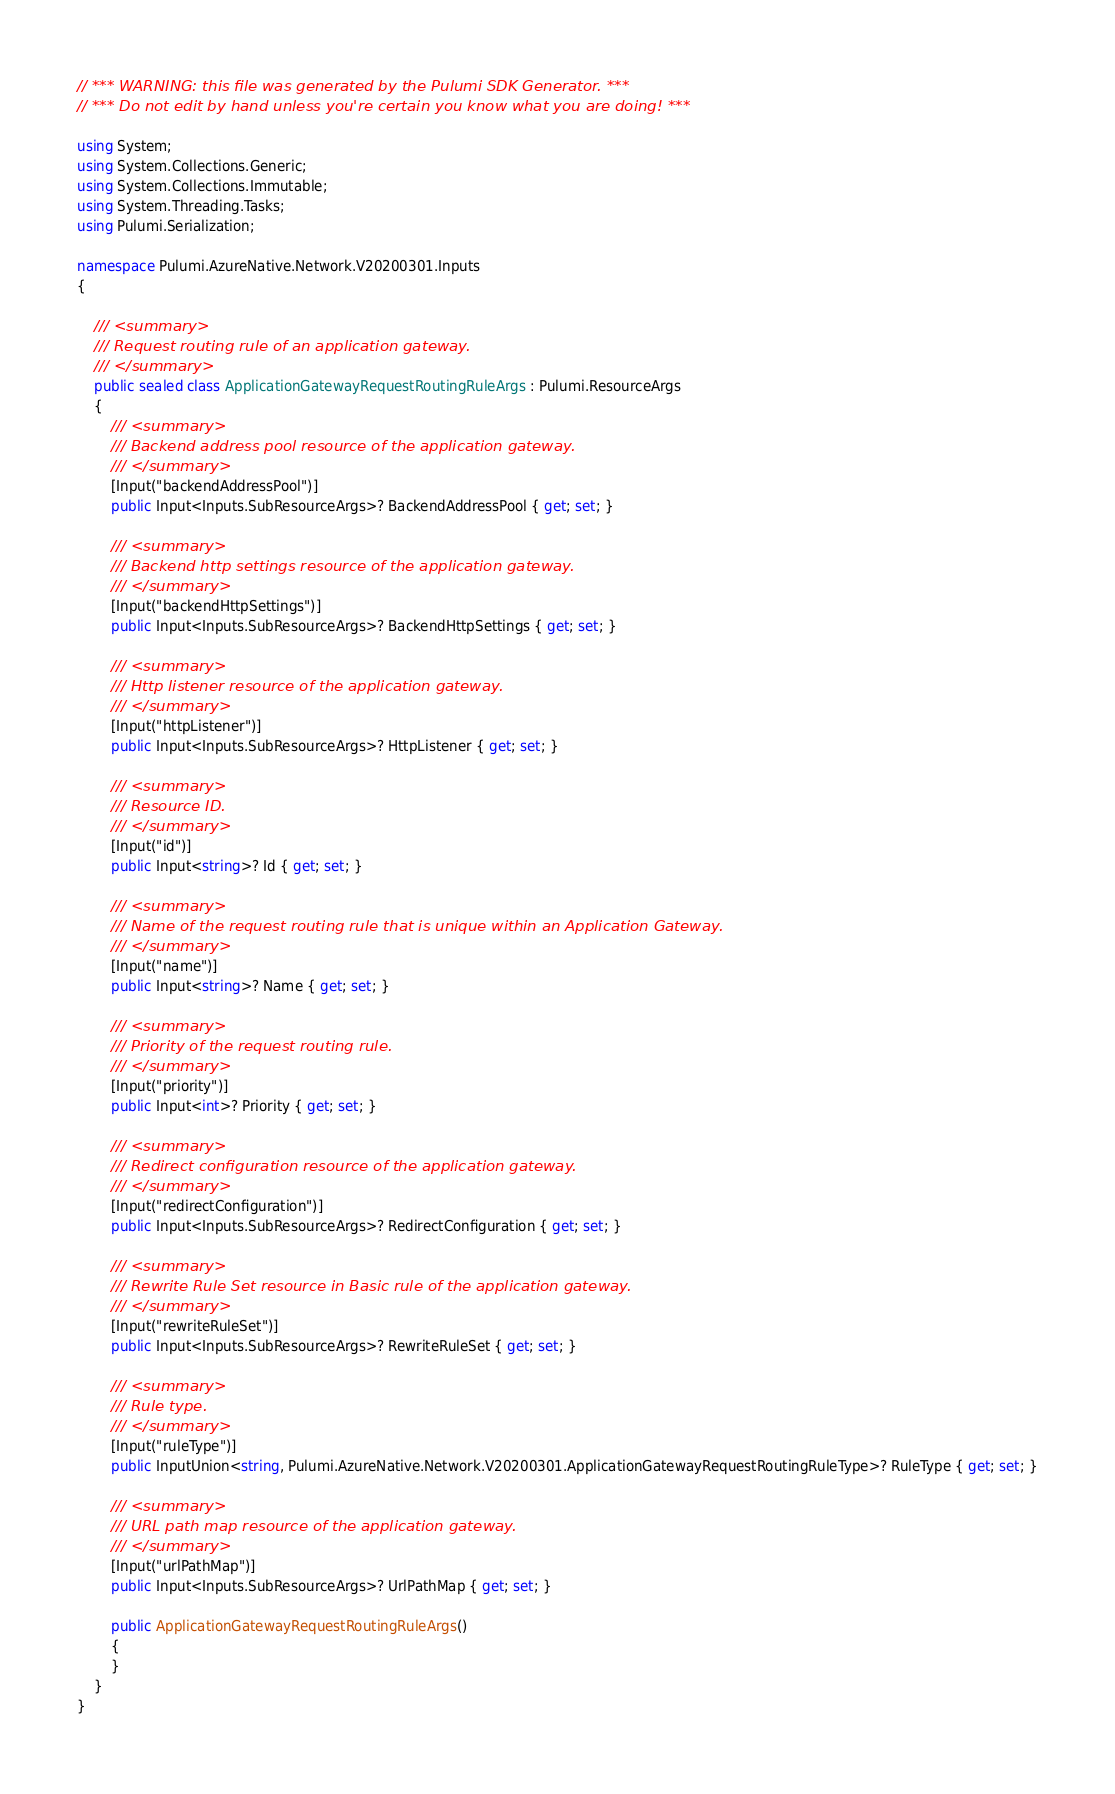Convert code to text. <code><loc_0><loc_0><loc_500><loc_500><_C#_>// *** WARNING: this file was generated by the Pulumi SDK Generator. ***
// *** Do not edit by hand unless you're certain you know what you are doing! ***

using System;
using System.Collections.Generic;
using System.Collections.Immutable;
using System.Threading.Tasks;
using Pulumi.Serialization;

namespace Pulumi.AzureNative.Network.V20200301.Inputs
{

    /// <summary>
    /// Request routing rule of an application gateway.
    /// </summary>
    public sealed class ApplicationGatewayRequestRoutingRuleArgs : Pulumi.ResourceArgs
    {
        /// <summary>
        /// Backend address pool resource of the application gateway.
        /// </summary>
        [Input("backendAddressPool")]
        public Input<Inputs.SubResourceArgs>? BackendAddressPool { get; set; }

        /// <summary>
        /// Backend http settings resource of the application gateway.
        /// </summary>
        [Input("backendHttpSettings")]
        public Input<Inputs.SubResourceArgs>? BackendHttpSettings { get; set; }

        /// <summary>
        /// Http listener resource of the application gateway.
        /// </summary>
        [Input("httpListener")]
        public Input<Inputs.SubResourceArgs>? HttpListener { get; set; }

        /// <summary>
        /// Resource ID.
        /// </summary>
        [Input("id")]
        public Input<string>? Id { get; set; }

        /// <summary>
        /// Name of the request routing rule that is unique within an Application Gateway.
        /// </summary>
        [Input("name")]
        public Input<string>? Name { get; set; }

        /// <summary>
        /// Priority of the request routing rule.
        /// </summary>
        [Input("priority")]
        public Input<int>? Priority { get; set; }

        /// <summary>
        /// Redirect configuration resource of the application gateway.
        /// </summary>
        [Input("redirectConfiguration")]
        public Input<Inputs.SubResourceArgs>? RedirectConfiguration { get; set; }

        /// <summary>
        /// Rewrite Rule Set resource in Basic rule of the application gateway.
        /// </summary>
        [Input("rewriteRuleSet")]
        public Input<Inputs.SubResourceArgs>? RewriteRuleSet { get; set; }

        /// <summary>
        /// Rule type.
        /// </summary>
        [Input("ruleType")]
        public InputUnion<string, Pulumi.AzureNative.Network.V20200301.ApplicationGatewayRequestRoutingRuleType>? RuleType { get; set; }

        /// <summary>
        /// URL path map resource of the application gateway.
        /// </summary>
        [Input("urlPathMap")]
        public Input<Inputs.SubResourceArgs>? UrlPathMap { get; set; }

        public ApplicationGatewayRequestRoutingRuleArgs()
        {
        }
    }
}
</code> 